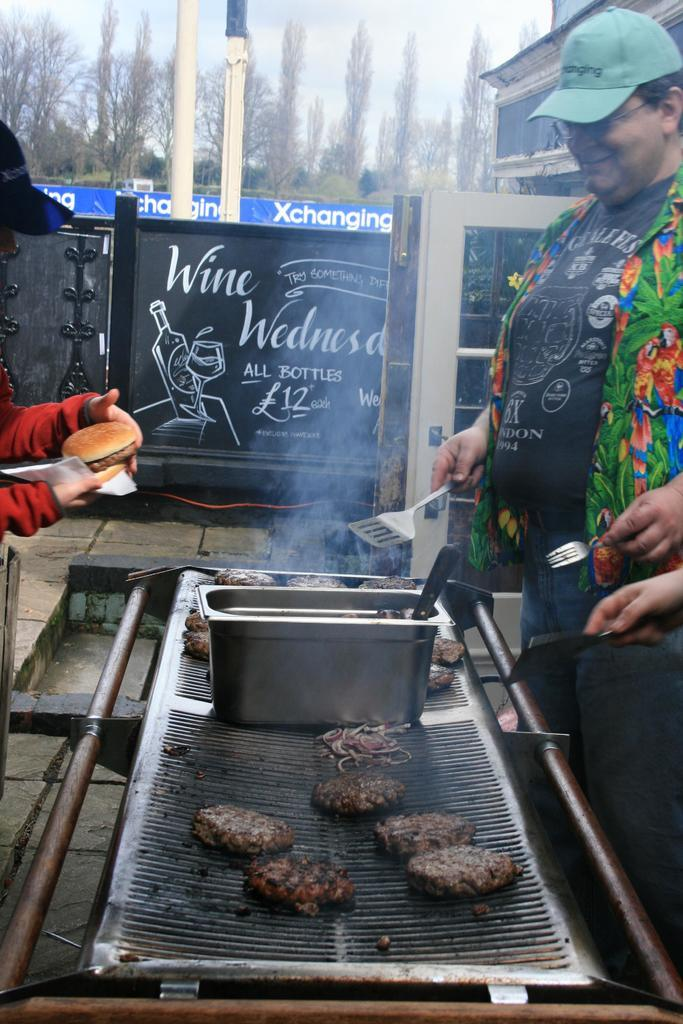<image>
Render a clear and concise summary of the photo. An outdoor grill with an advertising sign about wine 